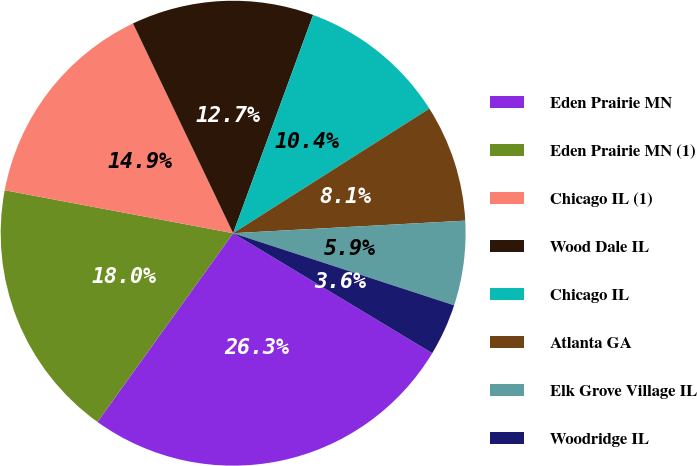<chart> <loc_0><loc_0><loc_500><loc_500><pie_chart><fcel>Eden Prairie MN<fcel>Eden Prairie MN (1)<fcel>Chicago IL (1)<fcel>Wood Dale IL<fcel>Chicago IL<fcel>Atlanta GA<fcel>Elk Grove Village IL<fcel>Woodridge IL<nl><fcel>26.29%<fcel>18.04%<fcel>14.95%<fcel>12.68%<fcel>10.41%<fcel>8.14%<fcel>5.88%<fcel>3.61%<nl></chart> 